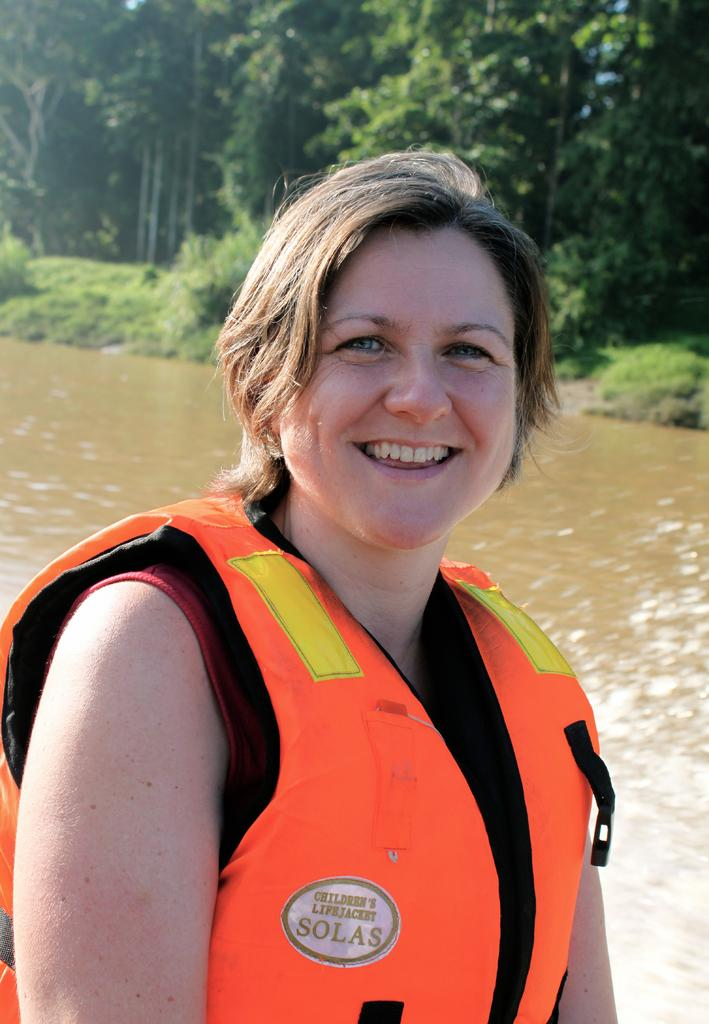Who is present in the image? There is a lady in the image. What type of vegetation can be seen in the image? There are plants and trees in the image. What natural element is visible in the image? There is water visible in the image. Can you see any squirrels interacting with the plants in the image? There are no squirrels present in the image. What type of space exploration equipment can be seen in the image? There is no space exploration equipment present in the image. 